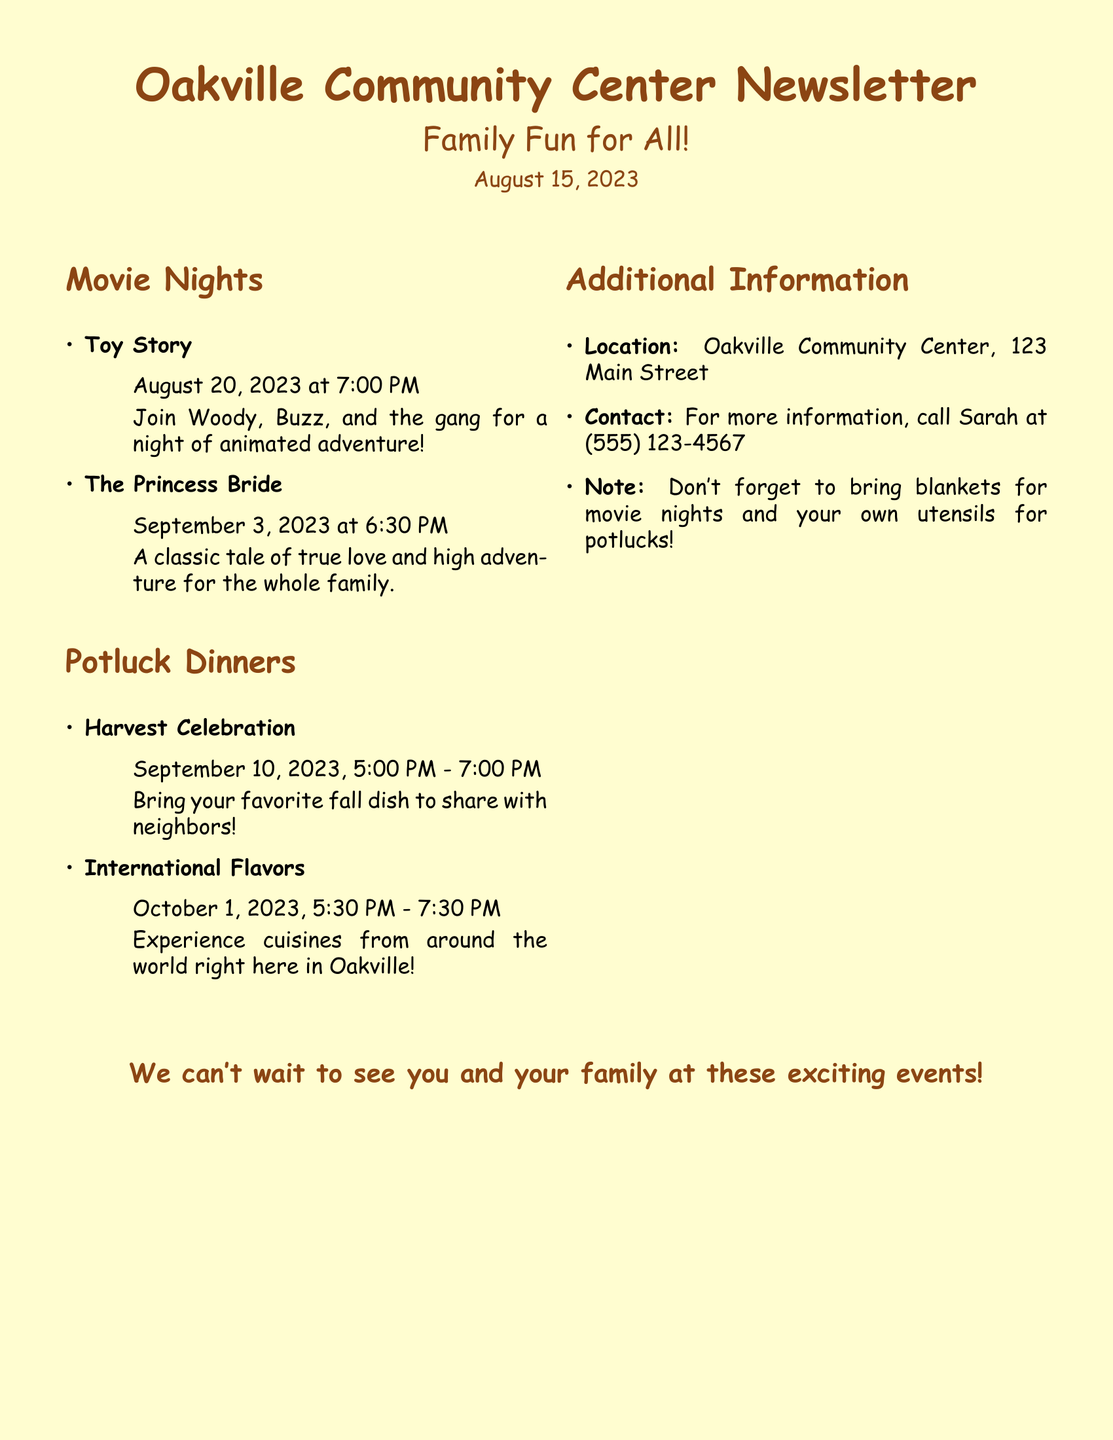What is the date of the movie night for Toy Story? The document specifies that Toy Story is showing on August 20, 2023.
Answer: August 20, 2023 What time does The Princess Bride movie night start? The document states the movie night for The Princess Bride begins at 6:30 PM.
Answer: 6:30 PM What is the theme of the first potluck dinner? The newsletter indicates the theme for the first potluck dinner is Harvest Celebration.
Answer: Harvest Celebration When is the International Flavors potluck dinner scheduled? The document shows that the International Flavors potluck dinner takes place on October 1, 2023.
Answer: October 1, 2023 Who can be contacted for more information about the events? The document provides a contact name, Sarah, for inquiries about the events.
Answer: Sarah What should families bring for the movie nights? According to the document, families are reminded to bring blankets for the movie nights.
Answer: Blankets What is the location of the Oakville Community Center? The location is mentioned as 123 Main Street in the document.
Answer: 123 Main Street What time does the Harvest Celebration potluck start? The newsletter states the Harvest Celebration potluck begins at 5:00 PM.
Answer: 5:00 PM How many movie nights are mentioned in the document? The document lists two movie nights: Toy Story and The Princess Bride.
Answer: Two 